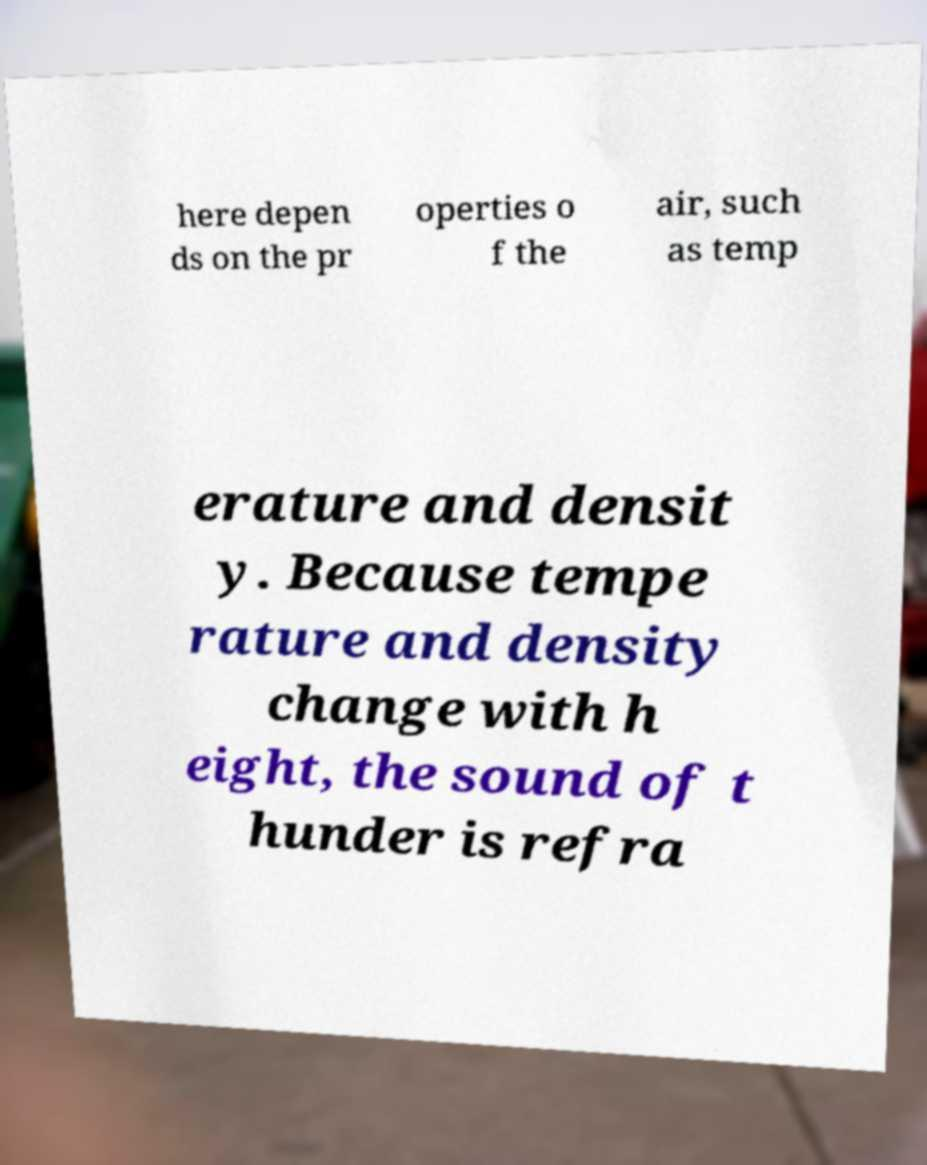For documentation purposes, I need the text within this image transcribed. Could you provide that? here depen ds on the pr operties o f the air, such as temp erature and densit y. Because tempe rature and density change with h eight, the sound of t hunder is refra 